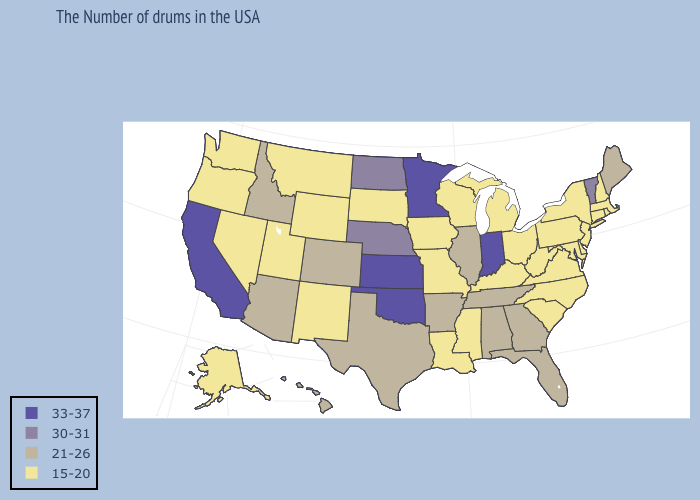Does California have the same value as Mississippi?
Short answer required. No. What is the value of Montana?
Answer briefly. 15-20. Name the states that have a value in the range 15-20?
Short answer required. Massachusetts, Rhode Island, New Hampshire, Connecticut, New York, New Jersey, Delaware, Maryland, Pennsylvania, Virginia, North Carolina, South Carolina, West Virginia, Ohio, Michigan, Kentucky, Wisconsin, Mississippi, Louisiana, Missouri, Iowa, South Dakota, Wyoming, New Mexico, Utah, Montana, Nevada, Washington, Oregon, Alaska. Does South Carolina have the same value as Minnesota?
Write a very short answer. No. What is the value of Illinois?
Short answer required. 21-26. What is the value of New Mexico?
Quick response, please. 15-20. What is the value of Oklahoma?
Write a very short answer. 33-37. Does Nebraska have the lowest value in the USA?
Concise answer only. No. Does North Dakota have the same value as Minnesota?
Quick response, please. No. Does Maine have a lower value than North Dakota?
Be succinct. Yes. How many symbols are there in the legend?
Answer briefly. 4. Does the map have missing data?
Be succinct. No. Does Tennessee have the highest value in the USA?
Keep it brief. No. 